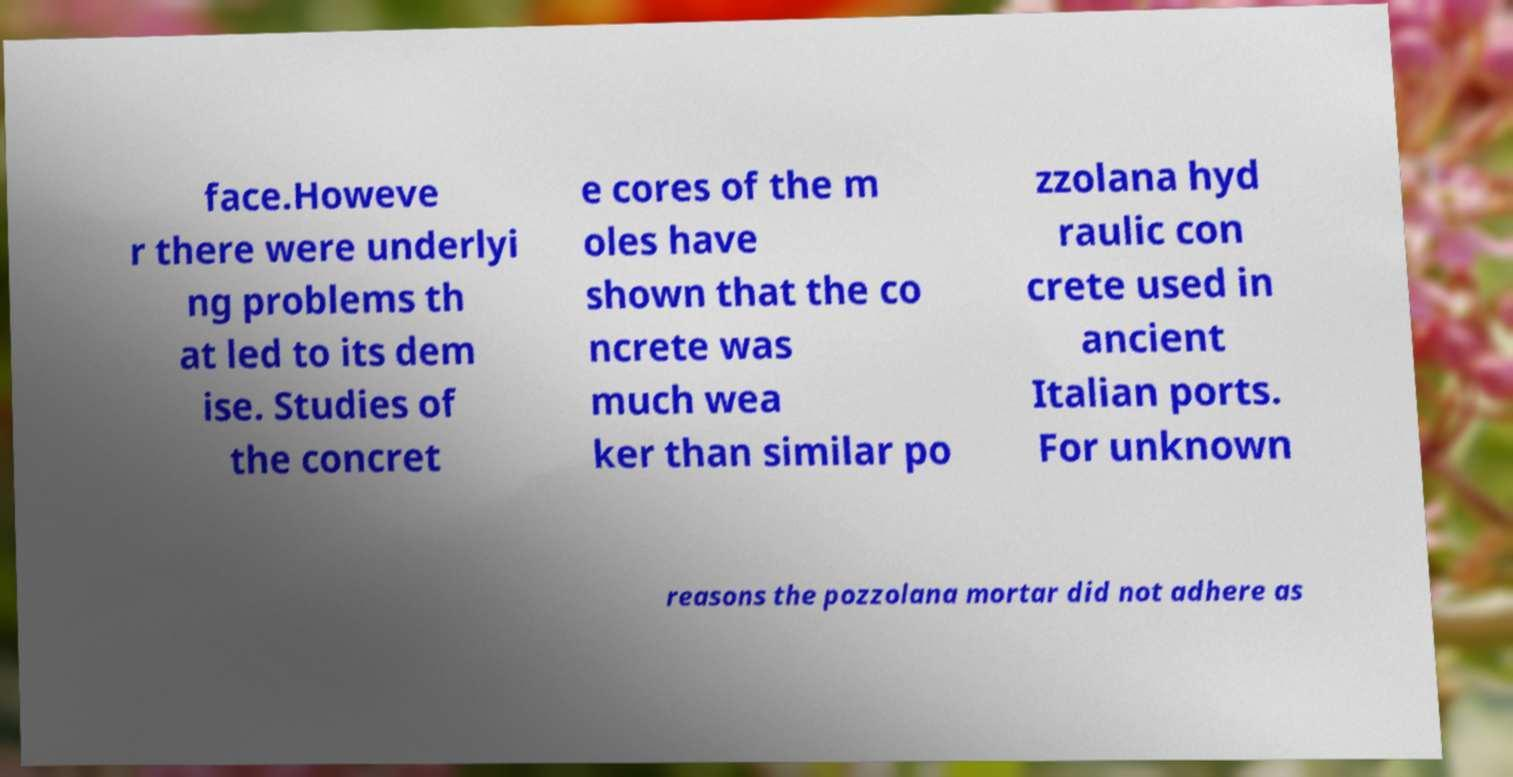Please identify and transcribe the text found in this image. face.Howeve r there were underlyi ng problems th at led to its dem ise. Studies of the concret e cores of the m oles have shown that the co ncrete was much wea ker than similar po zzolana hyd raulic con crete used in ancient Italian ports. For unknown reasons the pozzolana mortar did not adhere as 